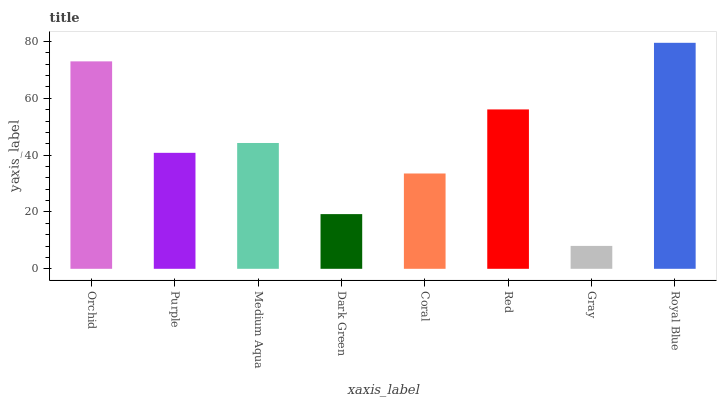Is Purple the minimum?
Answer yes or no. No. Is Purple the maximum?
Answer yes or no. No. Is Orchid greater than Purple?
Answer yes or no. Yes. Is Purple less than Orchid?
Answer yes or no. Yes. Is Purple greater than Orchid?
Answer yes or no. No. Is Orchid less than Purple?
Answer yes or no. No. Is Medium Aqua the high median?
Answer yes or no. Yes. Is Purple the low median?
Answer yes or no. Yes. Is Gray the high median?
Answer yes or no. No. Is Dark Green the low median?
Answer yes or no. No. 